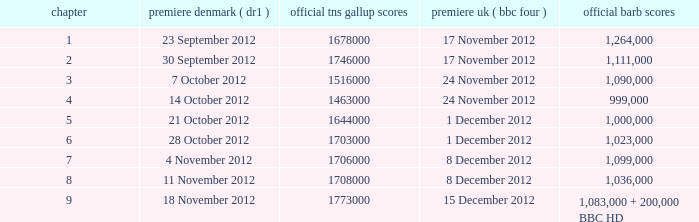When was the episode with a 999,000 BARB rating first aired in Denmark? 14 October 2012. 